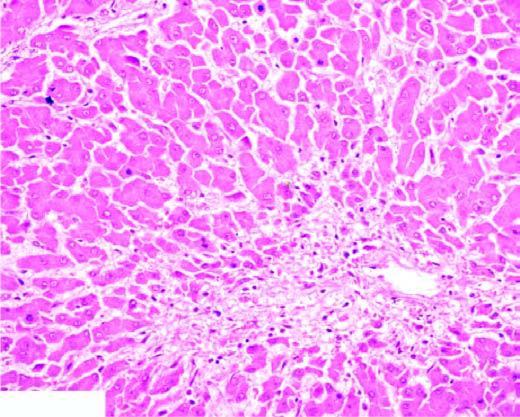does the centrilobular zone show marked degeneration and necrosis of hepatocytes accompanied by haemorrhage while the peripheral zone shows mild fatty change of liver cells?
Answer the question using a single word or phrase. Yes 